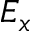<formula> <loc_0><loc_0><loc_500><loc_500>E _ { x }</formula> 